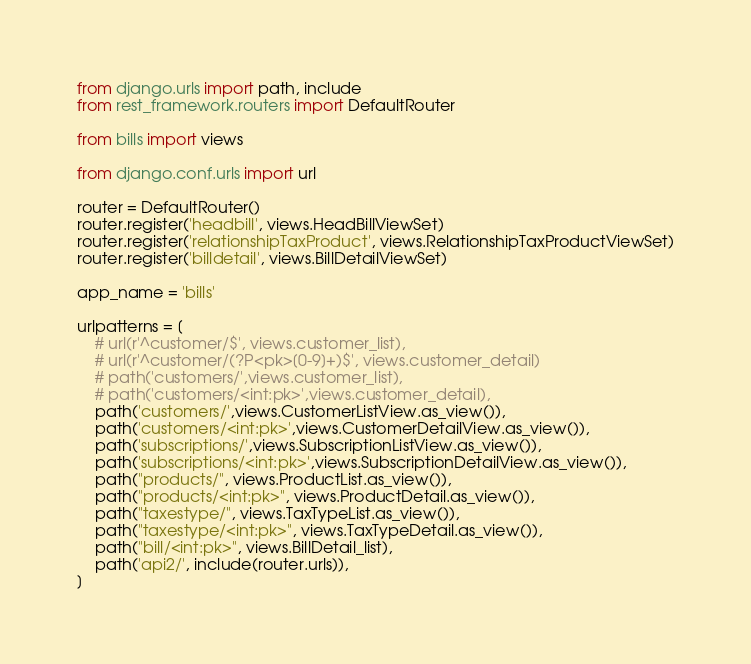<code> <loc_0><loc_0><loc_500><loc_500><_Python_>from django.urls import path, include
from rest_framework.routers import DefaultRouter

from bills import views

from django.conf.urls import url

router = DefaultRouter()
router.register('headbill', views.HeadBillViewSet)
router.register('relationshipTaxProduct', views.RelationshipTaxProductViewSet)
router.register('billdetail', views.BillDetailViewSet)

app_name = 'bills'

urlpatterns = [
    # url(r'^customer/$', views.customer_list),
    # url(r'^customer/(?P<pk>[0-9]+)$', views.customer_detail)
    # path('customers/',views.customer_list),
    # path('customers/<int:pk>',views.customer_detail),
    path('customers/',views.CustomerListView.as_view()),
    path('customers/<int:pk>',views.CustomerDetailView.as_view()),
    path('subscriptions/',views.SubscriptionListView.as_view()),
    path('subscriptions/<int:pk>',views.SubscriptionDetailView.as_view()),
    path("products/", views.ProductList.as_view()),
    path("products/<int:pk>", views.ProductDetail.as_view()),
    path("taxestype/", views.TaxTypeList.as_view()),
    path("taxestype/<int:pk>", views.TaxTypeDetail.as_view()),
    path("bill/<int:pk>", views.BillDetail_list),
    path('api2/', include(router.urls)),
]
</code> 